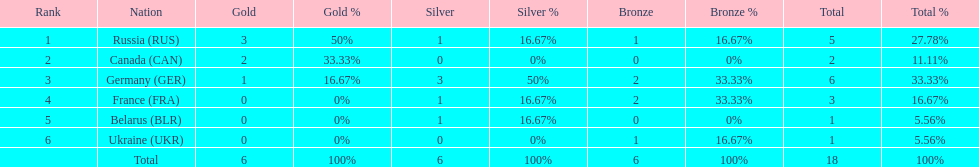How many silver medals did belarus win? 1. 